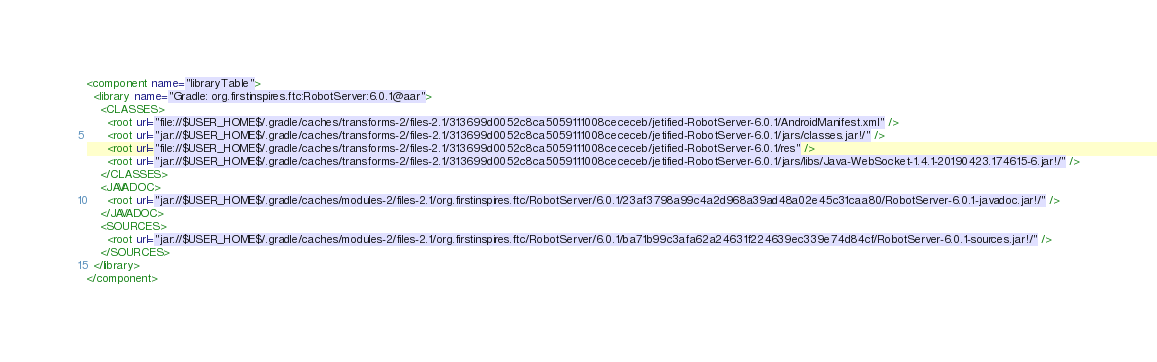<code> <loc_0><loc_0><loc_500><loc_500><_XML_><component name="libraryTable">
  <library name="Gradle: org.firstinspires.ftc:RobotServer:6.0.1@aar">
    <CLASSES>
      <root url="file://$USER_HOME$/.gradle/caches/transforms-2/files-2.1/313699d0052c8ca5059111008cececeb/jetified-RobotServer-6.0.1/AndroidManifest.xml" />
      <root url="jar://$USER_HOME$/.gradle/caches/transforms-2/files-2.1/313699d0052c8ca5059111008cececeb/jetified-RobotServer-6.0.1/jars/classes.jar!/" />
      <root url="file://$USER_HOME$/.gradle/caches/transforms-2/files-2.1/313699d0052c8ca5059111008cececeb/jetified-RobotServer-6.0.1/res" />
      <root url="jar://$USER_HOME$/.gradle/caches/transforms-2/files-2.1/313699d0052c8ca5059111008cececeb/jetified-RobotServer-6.0.1/jars/libs/Java-WebSocket-1.4.1-20190423.174615-6.jar!/" />
    </CLASSES>
    <JAVADOC>
      <root url="jar://$USER_HOME$/.gradle/caches/modules-2/files-2.1/org.firstinspires.ftc/RobotServer/6.0.1/23af3798a99c4a2d968a39ad48a02e45c31caa80/RobotServer-6.0.1-javadoc.jar!/" />
    </JAVADOC>
    <SOURCES>
      <root url="jar://$USER_HOME$/.gradle/caches/modules-2/files-2.1/org.firstinspires.ftc/RobotServer/6.0.1/ba71b99c3afa62a24631f224639ec339e74d84cf/RobotServer-6.0.1-sources.jar!/" />
    </SOURCES>
  </library>
</component></code> 